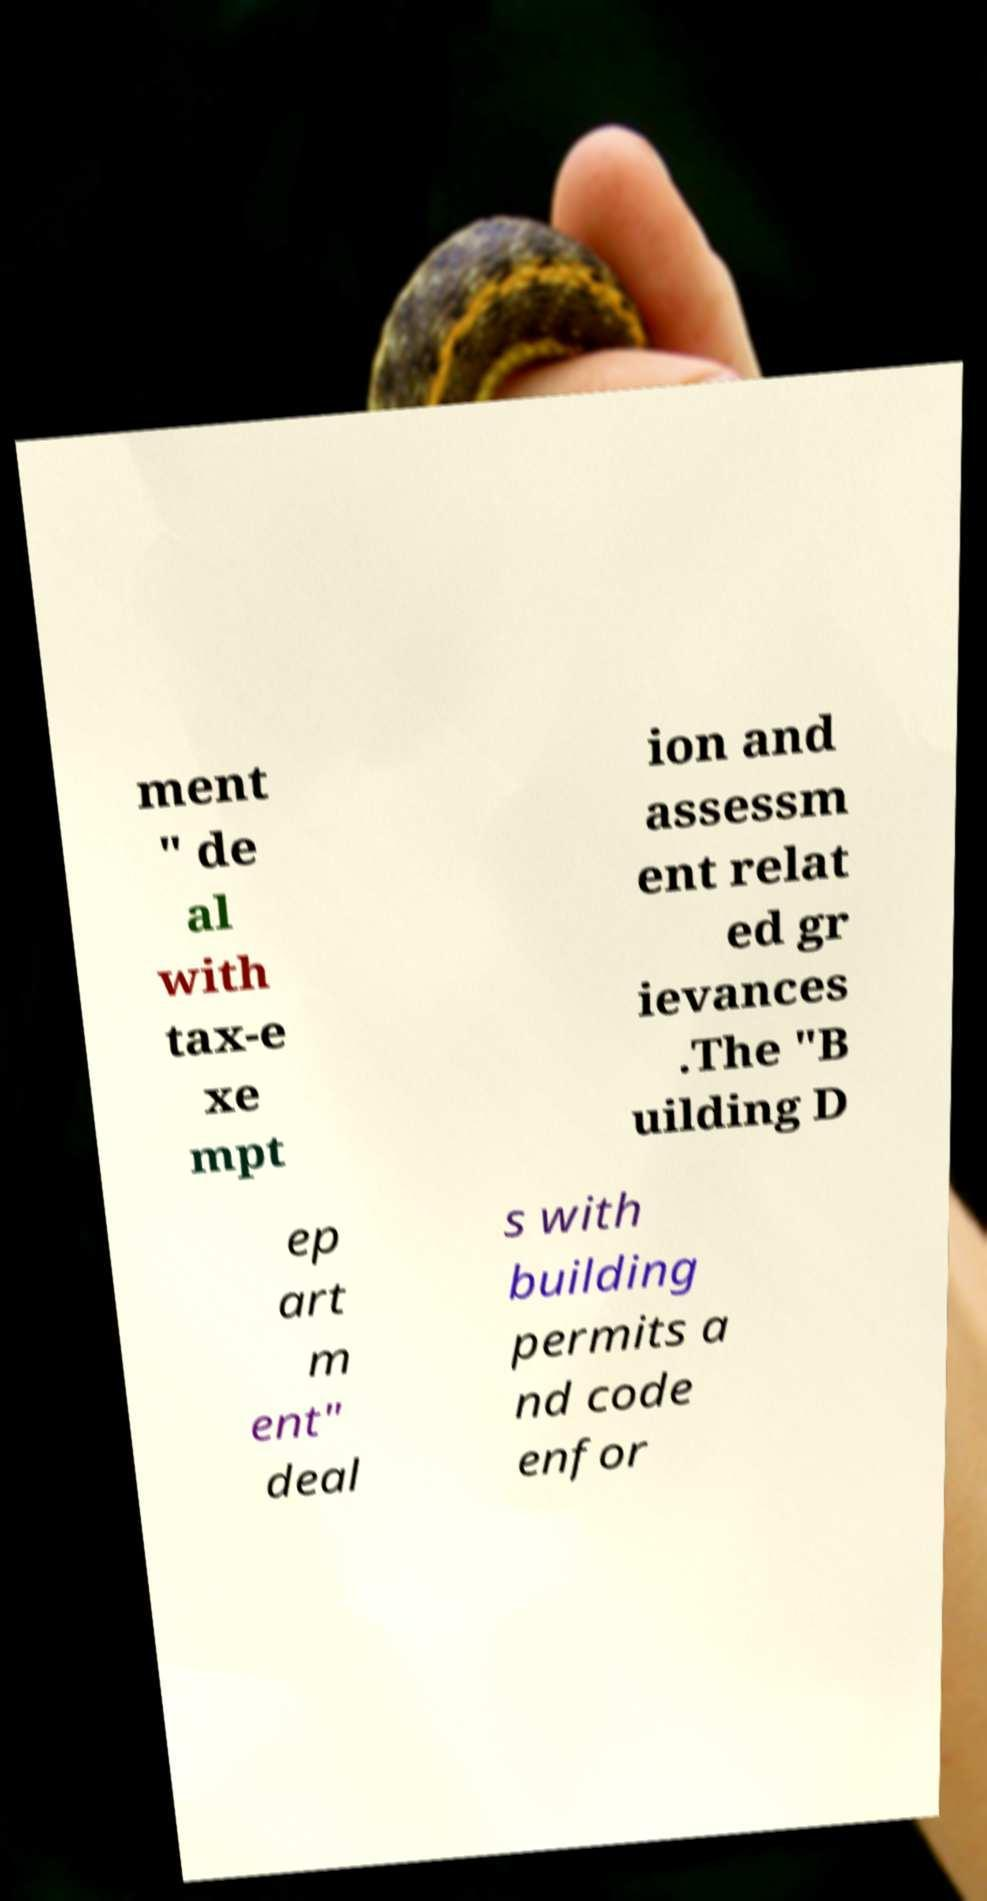For documentation purposes, I need the text within this image transcribed. Could you provide that? ment " de al with tax-e xe mpt ion and assessm ent relat ed gr ievances .The "B uilding D ep art m ent" deal s with building permits a nd code enfor 